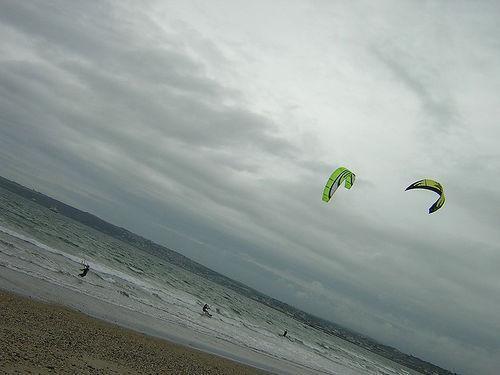How many kites are there?
Give a very brief answer. 2. 